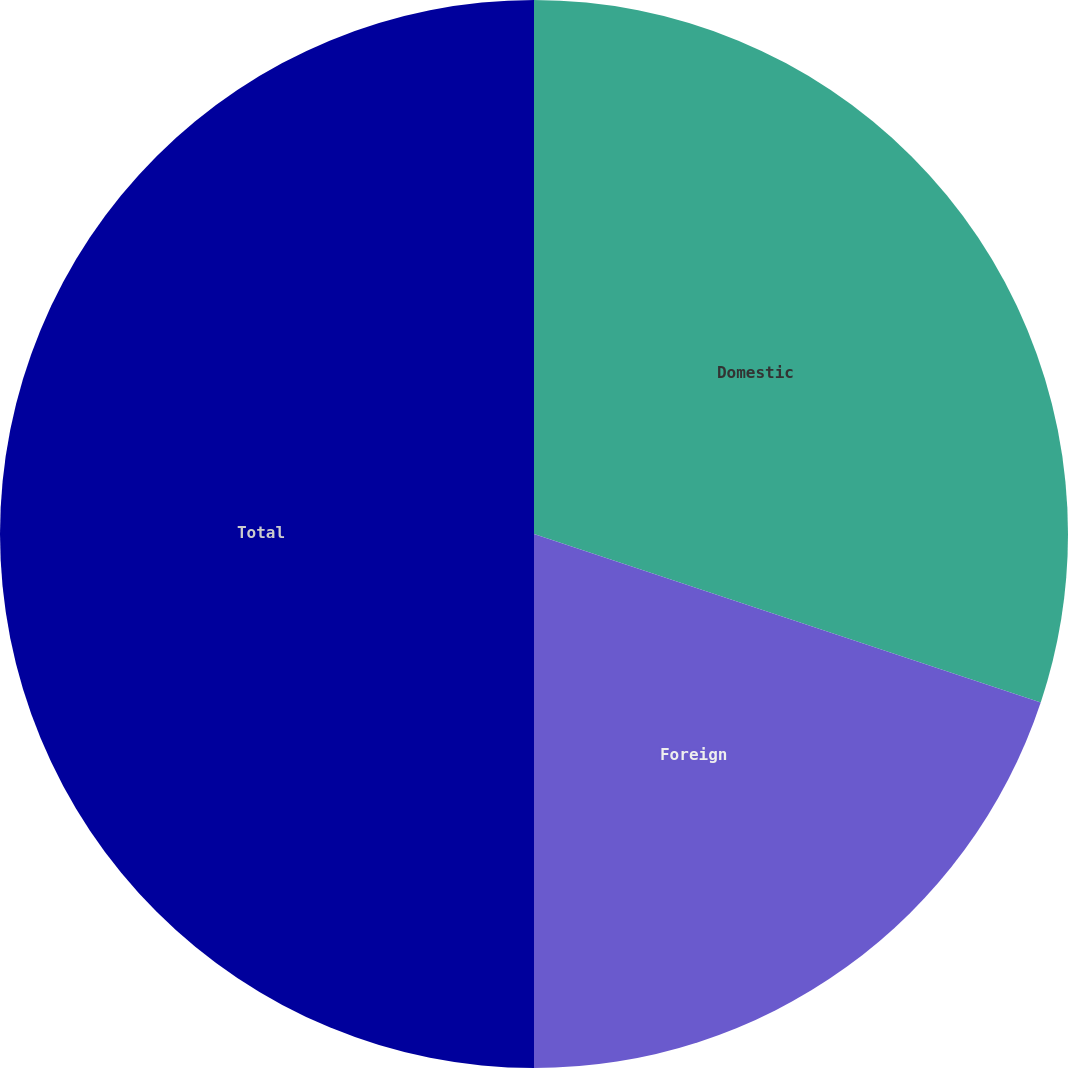Convert chart to OTSL. <chart><loc_0><loc_0><loc_500><loc_500><pie_chart><fcel>Domestic<fcel>Foreign<fcel>Total<nl><fcel>30.11%<fcel>19.89%<fcel>50.0%<nl></chart> 